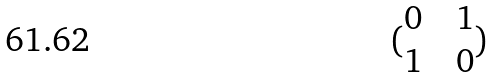Convert formula to latex. <formula><loc_0><loc_0><loc_500><loc_500>( \begin{matrix} 0 & & 1 \\ 1 & & 0 \end{matrix} )</formula> 